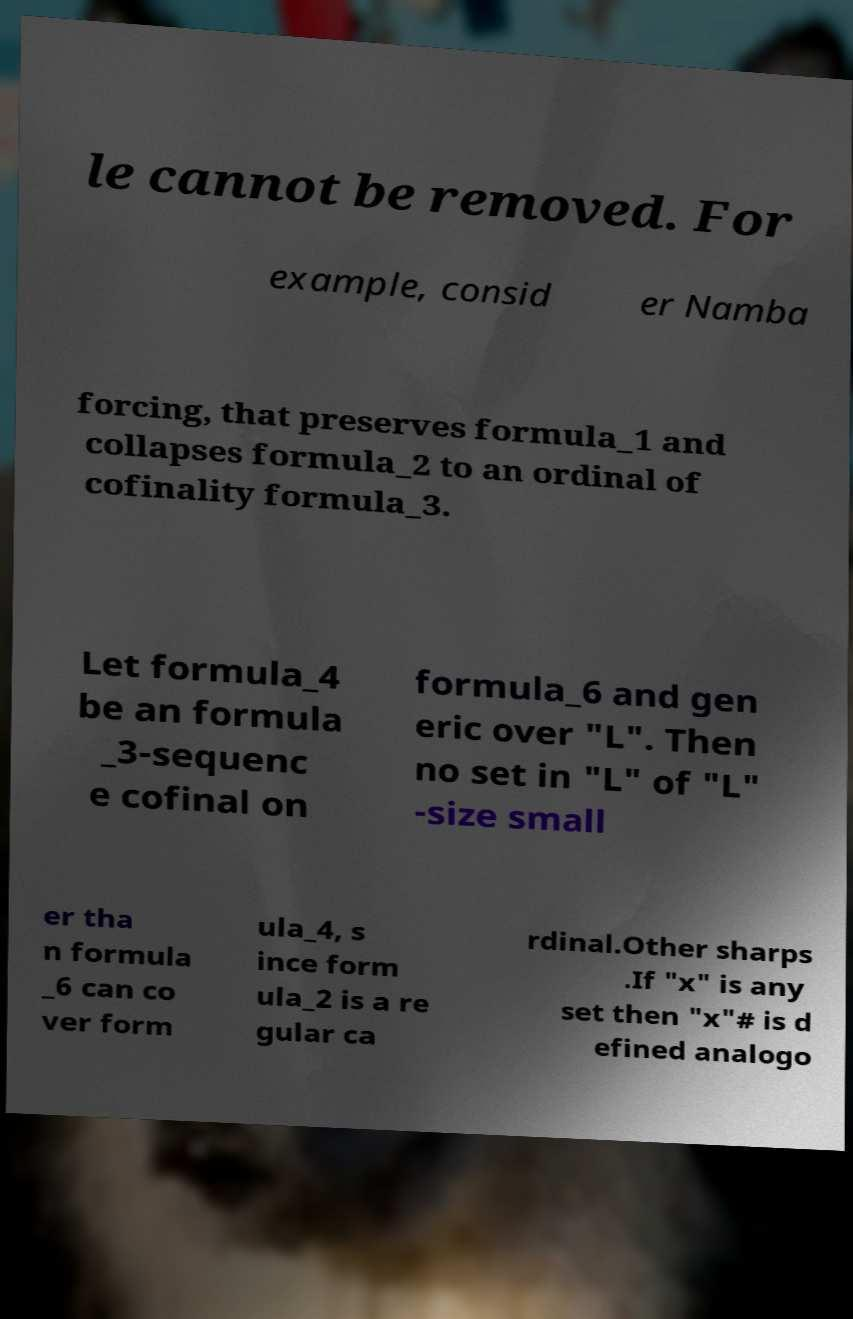Can you read and provide the text displayed in the image?This photo seems to have some interesting text. Can you extract and type it out for me? le cannot be removed. For example, consid er Namba forcing, that preserves formula_1 and collapses formula_2 to an ordinal of cofinality formula_3. Let formula_4 be an formula _3-sequenc e cofinal on formula_6 and gen eric over "L". Then no set in "L" of "L" -size small er tha n formula _6 can co ver form ula_4, s ince form ula_2 is a re gular ca rdinal.Other sharps .If "x" is any set then "x"# is d efined analogo 